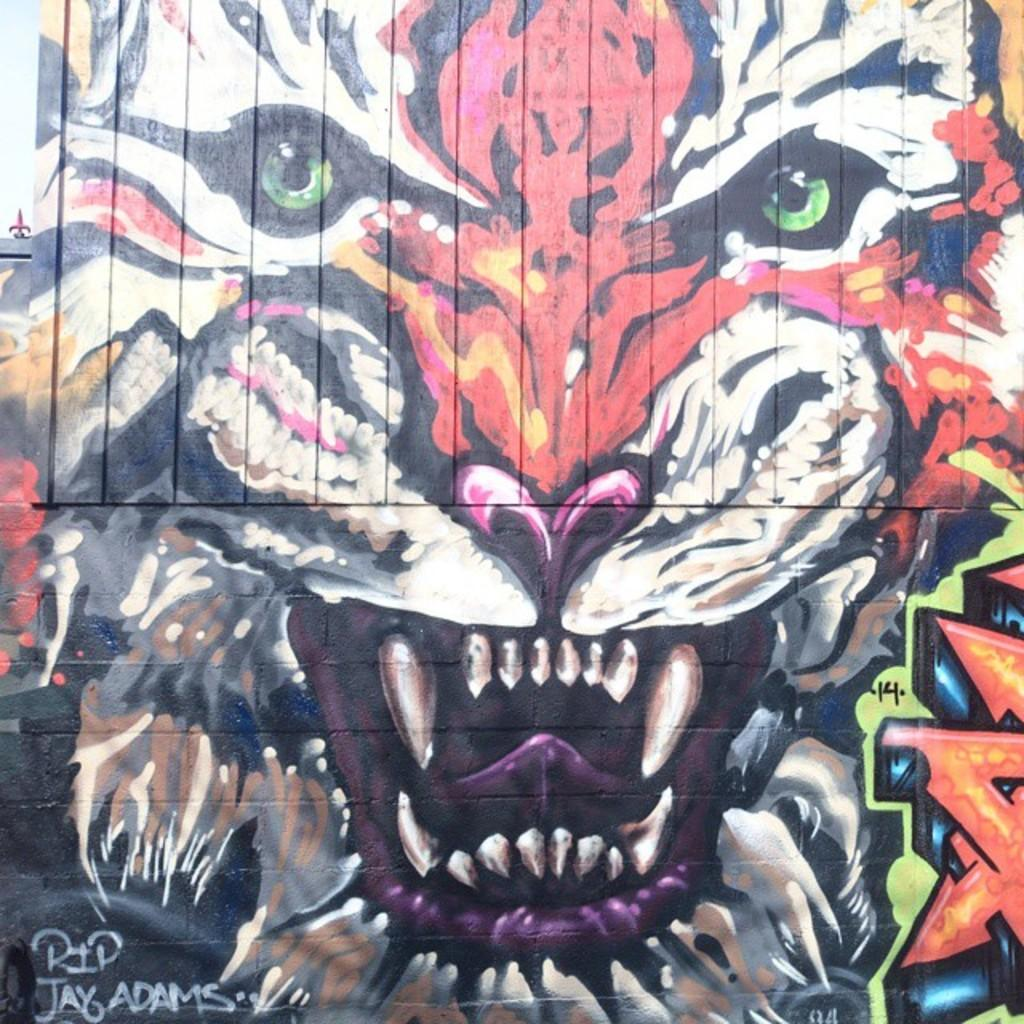What is depicted in the graffiti painting in the image? There is a graffiti painting of a tiger in the image. Where is the graffiti painting located? The graffiti painting is on a wall. How many bikes are parked near the graffiti painting in the image? There is no mention of bikes in the image, so we cannot determine how many bikes are present. 